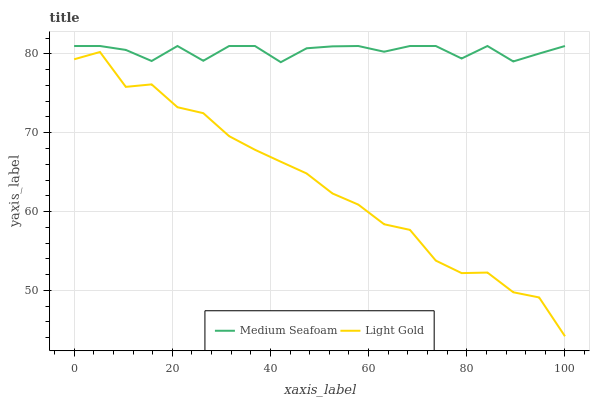Does Light Gold have the minimum area under the curve?
Answer yes or no. Yes. Does Medium Seafoam have the maximum area under the curve?
Answer yes or no. Yes. Does Medium Seafoam have the minimum area under the curve?
Answer yes or no. No. Is Medium Seafoam the smoothest?
Answer yes or no. Yes. Is Light Gold the roughest?
Answer yes or no. Yes. Is Medium Seafoam the roughest?
Answer yes or no. No. Does Light Gold have the lowest value?
Answer yes or no. Yes. Does Medium Seafoam have the lowest value?
Answer yes or no. No. Does Medium Seafoam have the highest value?
Answer yes or no. Yes. Is Light Gold less than Medium Seafoam?
Answer yes or no. Yes. Is Medium Seafoam greater than Light Gold?
Answer yes or no. Yes. Does Light Gold intersect Medium Seafoam?
Answer yes or no. No. 